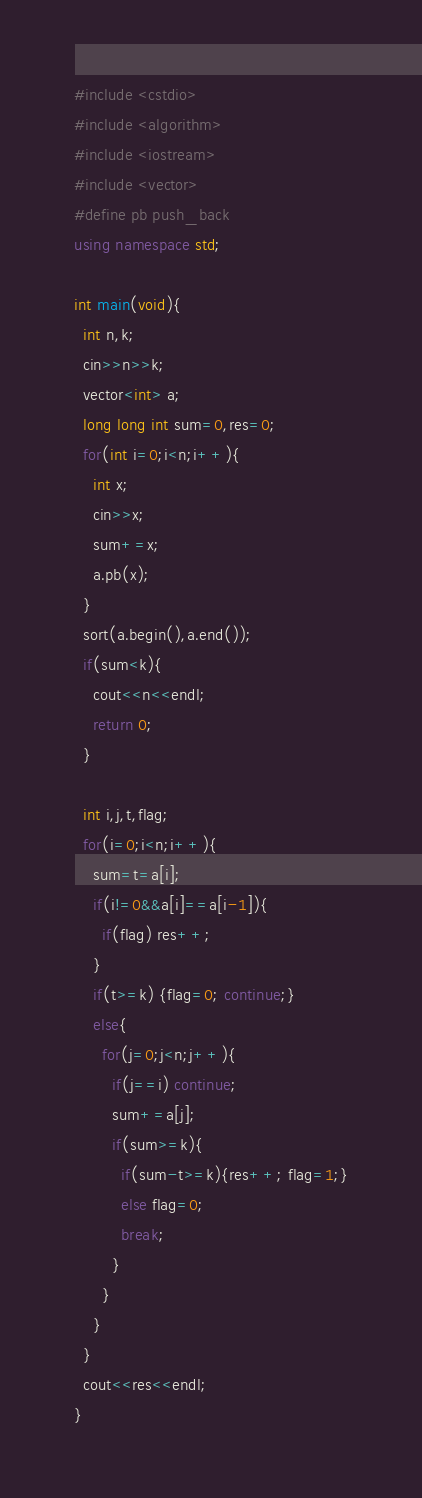<code> <loc_0><loc_0><loc_500><loc_500><_C++_>#include <cstdio>
#include <algorithm>
#include <iostream>
#include <vector>
#define pb push_back
using namespace std;

int main(void){
  int n,k;
  cin>>n>>k;
  vector<int> a;
  long long int sum=0,res=0;
  for(int i=0;i<n;i++){
    int x;
    cin>>x;
    sum+=x;
    a.pb(x);
  }
  sort(a.begin(),a.end());
  if(sum<k){
    cout<<n<<endl;
    return 0;
  }

  int i,j,t,flag;
  for(i=0;i<n;i++){
    sum=t=a[i];
    if(i!=0&&a[i]==a[i-1]){
      if(flag) res++;
    }
    if(t>=k) {flag=0; continue;}
    else{
      for(j=0;j<n;j++){
        if(j==i) continue;
        sum+=a[j];
        if(sum>=k){
          if(sum-t>=k){res++; flag=1;}
          else flag=0;
          break;
        }
      }
    }
  }
  cout<<res<<endl;
}</code> 